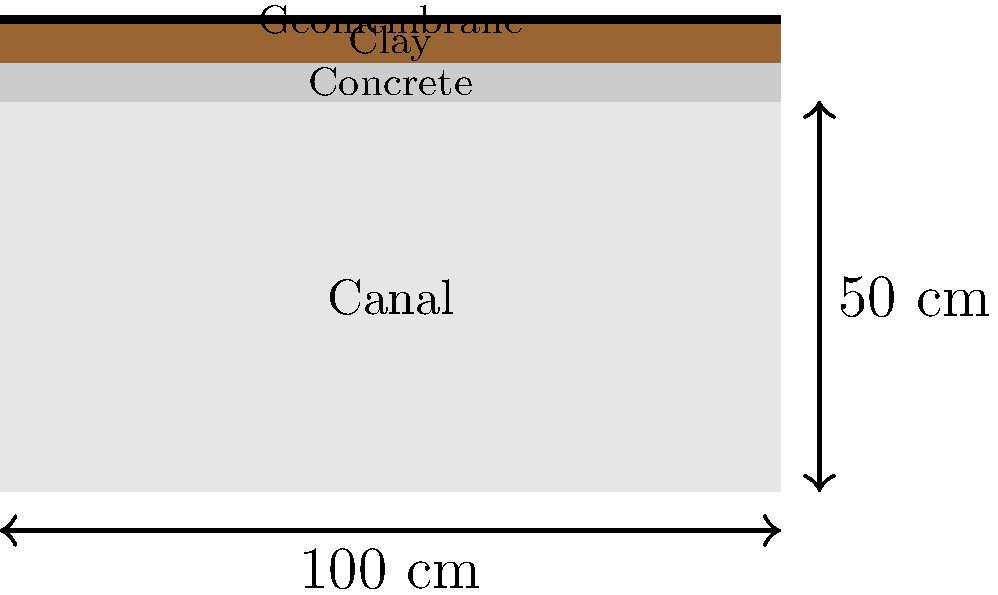Based on the cross-sectional view of canal lining materials shown above, which material would be most suitable for preventing water seepage in the Qosh Tepa Canal, considering its thin layer and impermeability? To determine the most suitable material for preventing water seepage in the Qosh Tepa Canal, we need to consider the properties of each lining material shown in the cross-sectional view:

1. Concrete:
   - Relatively thick layer (5 cm)
   - Good durability and strength
   - Moderate impermeability

2. Clay:
   - Thick layer (5 cm)
   - Natural material, easily available
   - Moderate impermeability, but can crack when dry

3. Geomembrane:
   - Very thin layer (1 cm)
   - Synthetic material
   - Highly impermeable

Comparing these materials:

1. Thickness: Geomembrane is the thinnest, which can be advantageous for installation and cost-effectiveness.

2. Impermeability: Geomembrane offers the highest level of impermeability among the three options, which is crucial for preventing water seepage.

3. Durability: While concrete and clay are more resistant to physical damage, geomembranes are designed to withstand various environmental conditions and maintain their impermeability over time.

4. Installation: Geomembranes are relatively easy to install compared to concrete and clay linings, which is beneficial for large-scale projects like the Qosh Tepa Canal.

5. Cost-effectiveness: Due to its thinness and high performance, geomembranes often provide a good balance between cost and effectiveness in preventing water seepage.

Considering these factors, the geomembrane would be the most suitable material for preventing water seepage in the Qosh Tepa Canal, primarily due to its thin layer and superior impermeability.
Answer: Geomembrane 